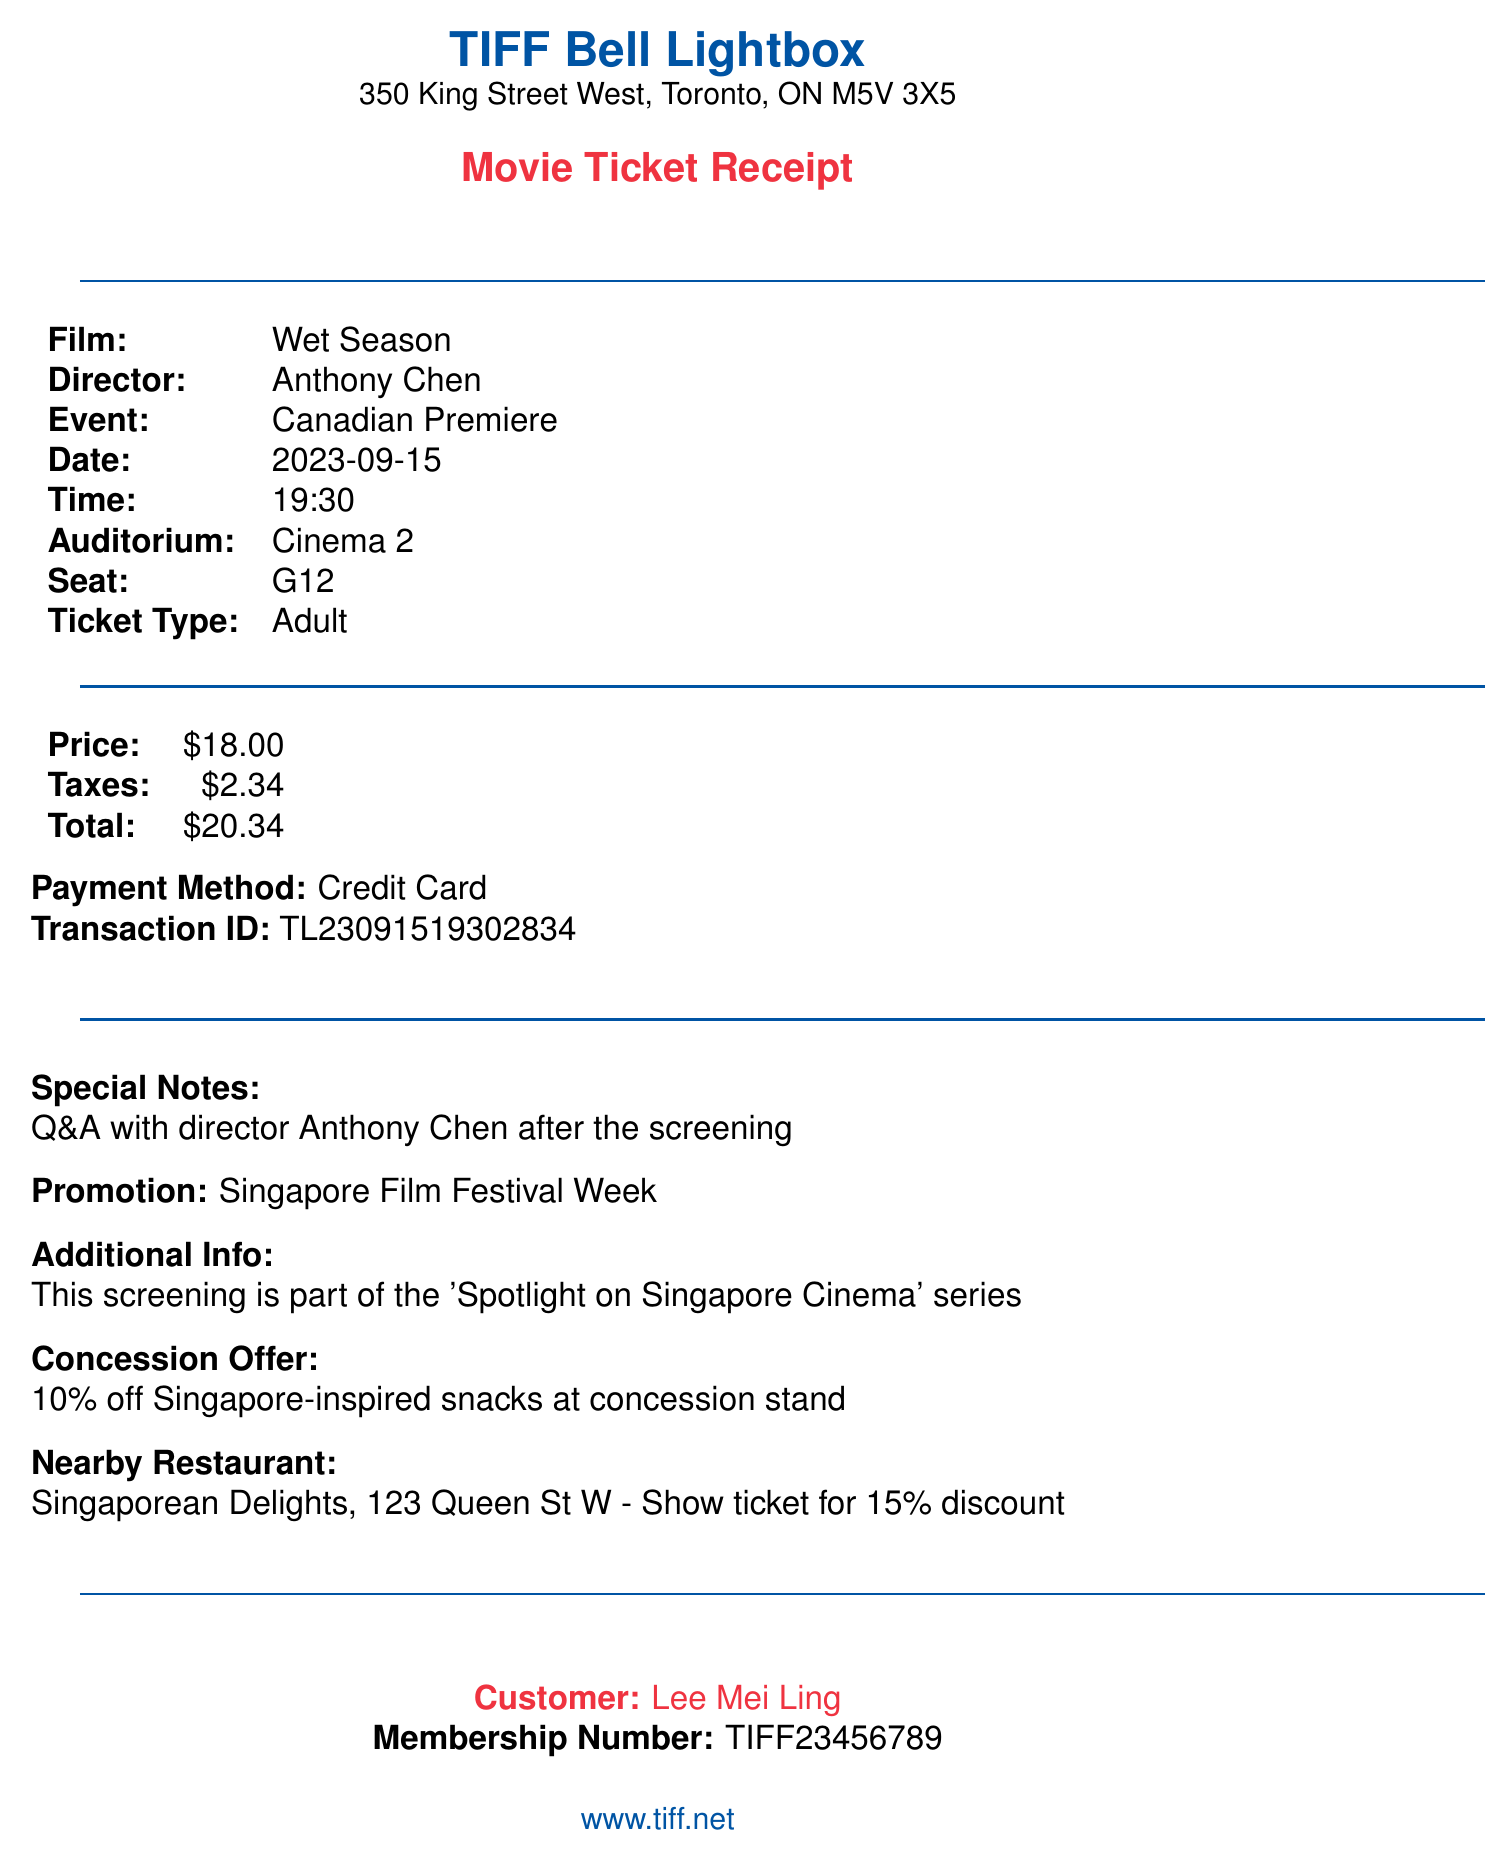what is the theater name? The theater name is listed prominently at the top of the receipt.
Answer: TIFF Bell Lightbox what is the film title? The film title is clearly stated in the receipt under the film section.
Answer: Wet Season who is the director of the film? The director's name is provided alongside the film title on the receipt.
Answer: Anthony Chen what is the date of the event? The date of the event is specified in the document, indicating when the screening occurred.
Answer: 2023-09-15 how much was the total cost of the ticket? The total cost is shown in the payment summary section of the receipt.
Answer: $20.34 what is the seat number? The seat number is indicated in the seating information on the receipt.
Answer: G12 what is the promotion associated with the screening? The promotion is mentioned in a dedicated section to highlight special offers for this event.
Answer: Singapore Film Festival Week what is the nearby restaurant? The nearby restaurant offering a discount is explicitly noted in the additional offerings on the receipt.
Answer: Singaporean Delights what does the special notes section mention? This section includes important information about an engagement following the film, which is listed on the receipt.
Answer: Q&A with director Anthony Chen after the screening what discount do you get at the concession stand? The discount available at the concession stand is detailed in the concessions offer section.
Answer: 10% off 